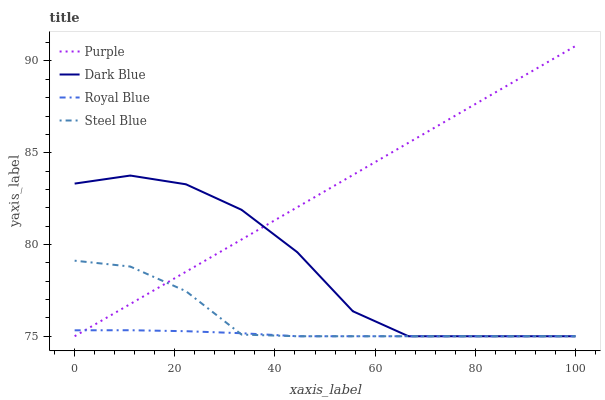Does Royal Blue have the minimum area under the curve?
Answer yes or no. Yes. Does Purple have the maximum area under the curve?
Answer yes or no. Yes. Does Dark Blue have the minimum area under the curve?
Answer yes or no. No. Does Dark Blue have the maximum area under the curve?
Answer yes or no. No. Is Purple the smoothest?
Answer yes or no. Yes. Is Dark Blue the roughest?
Answer yes or no. Yes. Is Steel Blue the smoothest?
Answer yes or no. No. Is Steel Blue the roughest?
Answer yes or no. No. Does Purple have the lowest value?
Answer yes or no. Yes. Does Purple have the highest value?
Answer yes or no. Yes. Does Dark Blue have the highest value?
Answer yes or no. No. Does Purple intersect Steel Blue?
Answer yes or no. Yes. Is Purple less than Steel Blue?
Answer yes or no. No. Is Purple greater than Steel Blue?
Answer yes or no. No. 